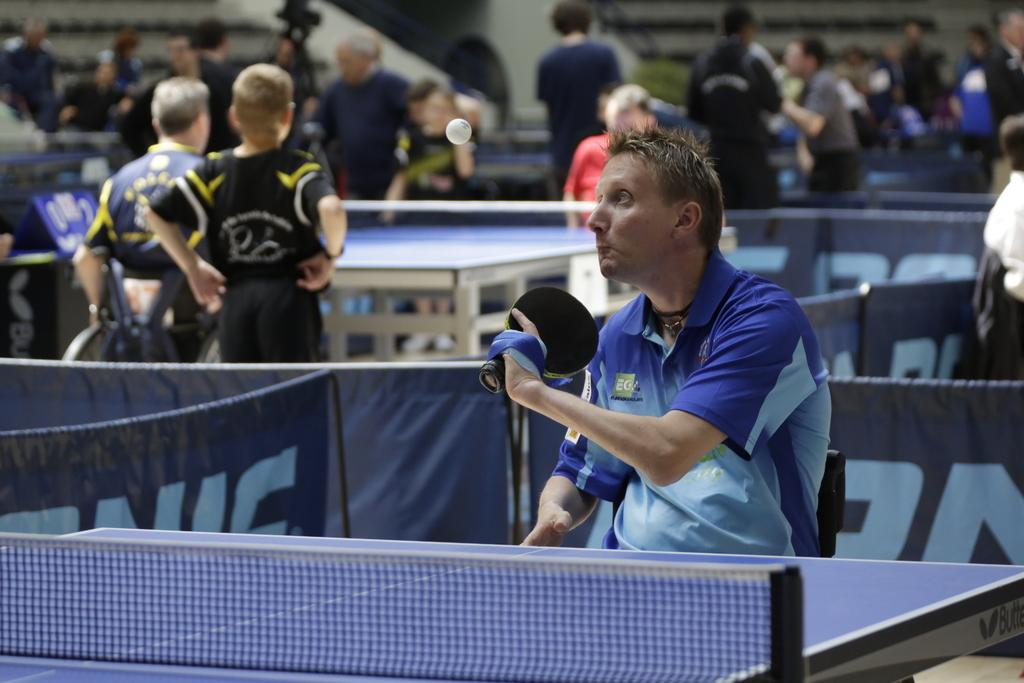Who is present in the image? There is a man in the image. What is the man holding in the image? The man is holding a bat. What is in front of the man in the image? There is a table in front of the man. Can you describe the background of the image? There are people and another table in the background of the image. What type of chain can be seen hanging from the flower in the image? There is no chain or flower present in the image. 